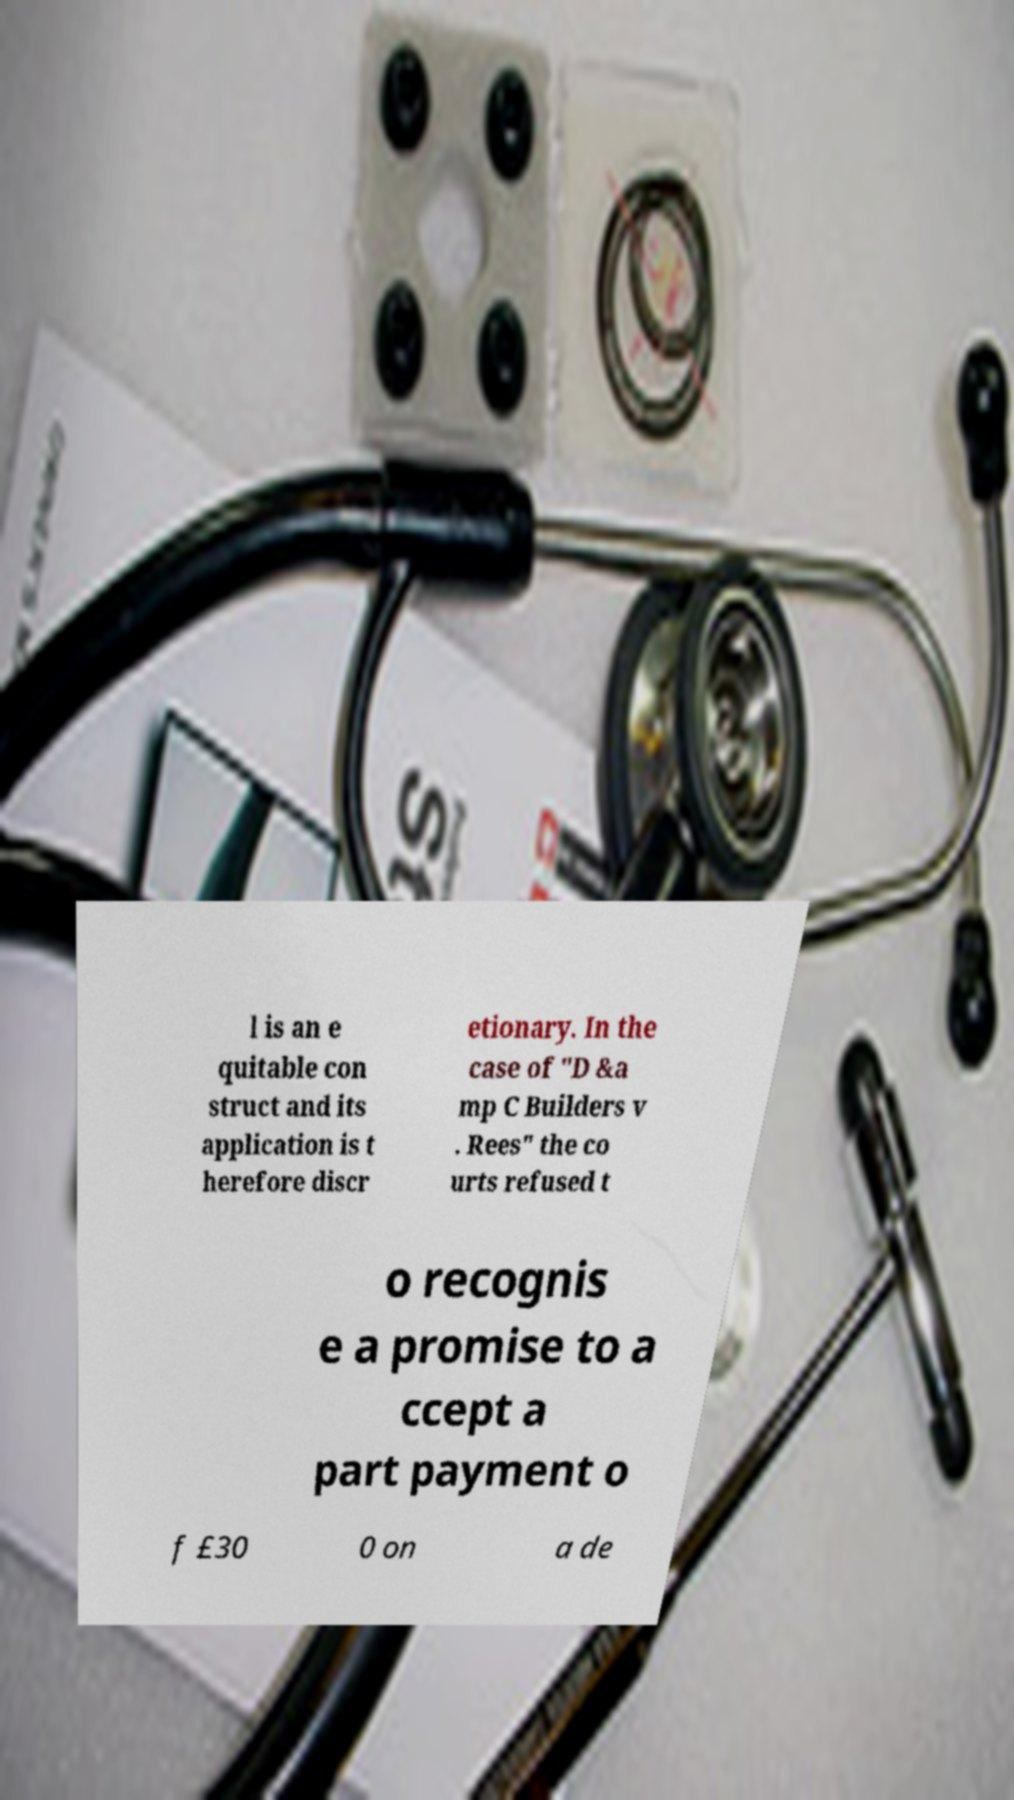Please identify and transcribe the text found in this image. l is an e quitable con struct and its application is t herefore discr etionary. In the case of "D &a mp C Builders v . Rees" the co urts refused t o recognis e a promise to a ccept a part payment o f £30 0 on a de 